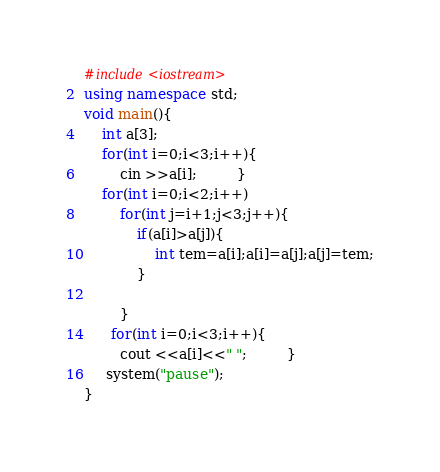Convert code to text. <code><loc_0><loc_0><loc_500><loc_500><_C++_>#include<iostream>
using namespace std;
void main(){
	int a[3];
	for(int i=0;i<3;i++){
		cin >>a[i];		 }
	for(int i=0;i<2;i++)
		for(int j=i+1;j<3;j++){
			if(a[i]>a[j]){
				int tem=a[i];a[i]=a[j];a[j]=tem;
			}
			
		}
	  for(int i=0;i<3;i++){
		cout <<a[i]<<" ";		 }
	 system("pause");
}</code> 